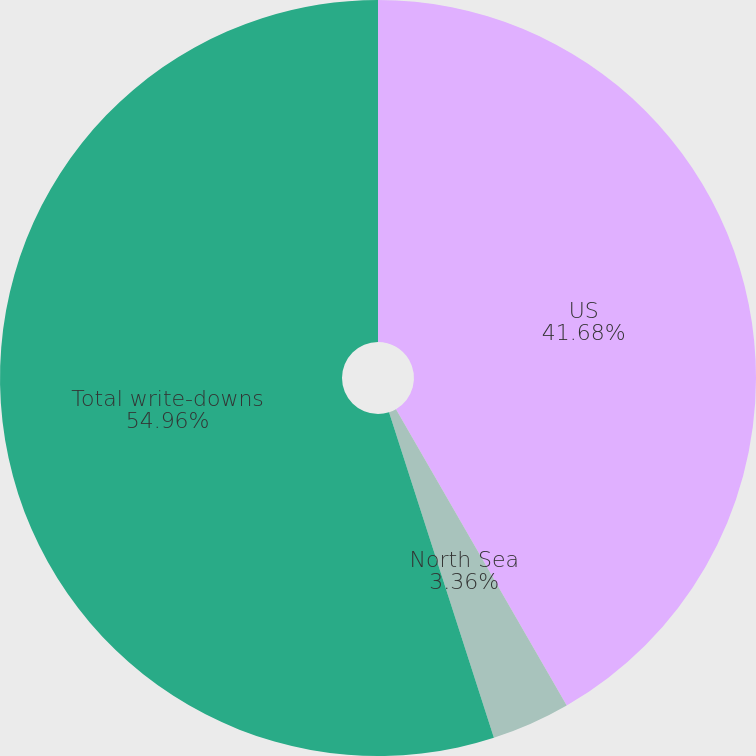Convert chart. <chart><loc_0><loc_0><loc_500><loc_500><pie_chart><fcel>US<fcel>North Sea<fcel>Total write-downs<nl><fcel>41.68%<fcel>3.36%<fcel>54.96%<nl></chart> 